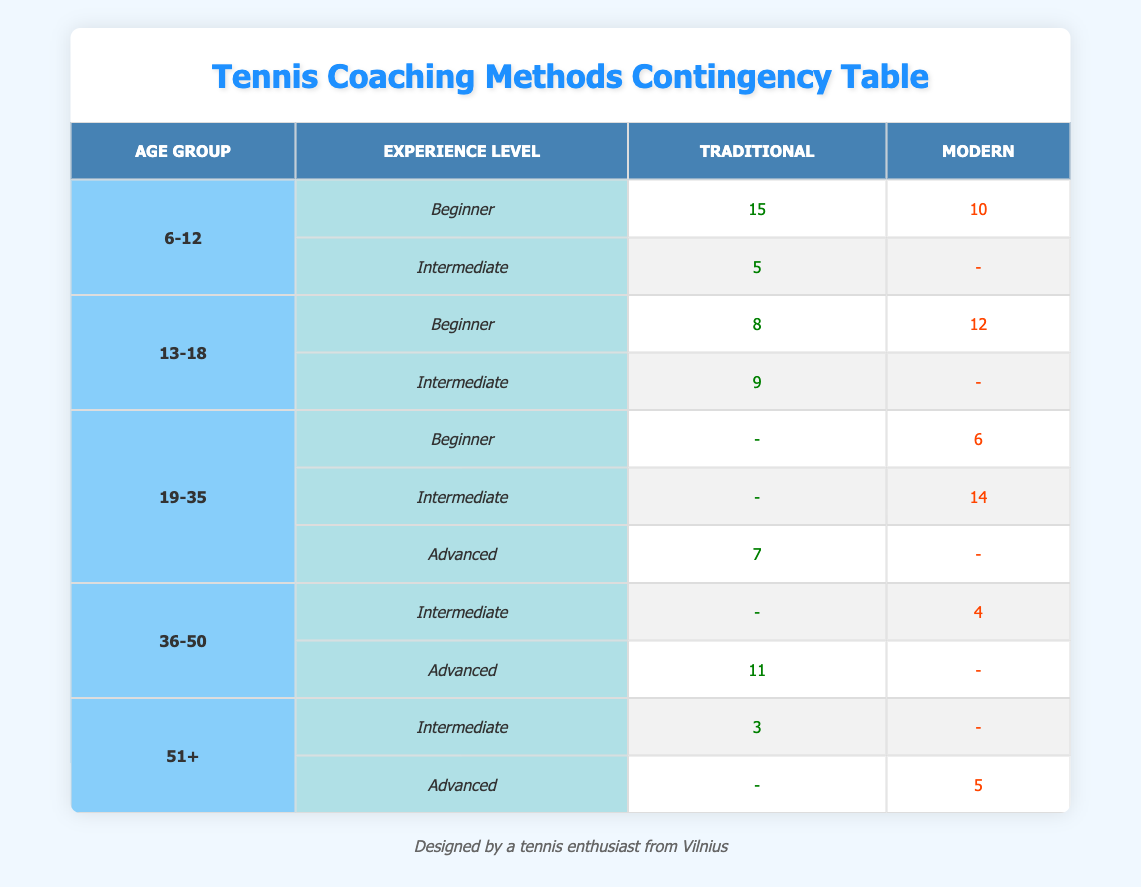What is the count of beginners in the age group 6-12 who prefer traditional coaching methods? In the table, under the age group 6-12 and experience level Beginner, the count for traditional coaching methods is 15.
Answer: 15 How many total responses are there for the age group 19-35? For the age group 19-35, the counts are: 6 (Beginner, Modern), 14 (Intermediate, Modern), and 7 (Advanced, Traditional). Summing these gives 6 + 14 + 7 = 27.
Answer: 27 Is there any age group that has no responses for the modern coaching method? Examining the table, the 6-12 and 36-50 age groups have counts for all experience levels with modern coaching methods, but the age group 51+ has no responses for Intermediate modern coaching. Therefore, the answer is yes.
Answer: Yes What is the total count of individuals in the age group 36-50 that prefer traditional coaching methods? For the age group 36-50, the counts for traditional coaching methods are: 11 (Advanced) and 0 (Intermediate). Adding these gives 11 + 0 = 11.
Answer: 11 Which coaching method is more preferred by beginners in the age group 13-18? Looking at the age group 13-18 for beginners, the count for traditional coaching methods is 8, while for modern methods it is 12. Since 12 is greater than 8, modern coaching methods are preferred.
Answer: Modern How many more individuals in the age group 51+ prefer advanced modern coaching methods compared to intermediate traditional methods? For the age group 51+, the count for advanced modern coaching methods is 5 and for intermediate traditional methods it is 3. Thus, there are 5 - 3 = 2 more individuals preferring advanced modern coaching methods.
Answer: 2 What is the age group with the highest count for traditional coaching methods, and what is that count? Assessing the counts for traditional coaching methods across all age groups: 15 (6-12, Beginner), 9 (13-18, Intermediate), 7 (19-35, Advanced), 11 (36-50, Advanced), and 3 (51+, Intermediate). The highest count is 15 in the age group 6-12.
Answer: 6-12, 15 Are there more beginners or advanced individuals preferring modern coaching methods across all age groups combined? Summing all counts for beginners in modern coaching methods yields 10 (6-12) + 12 (13-18) + 6 (19-35) = 28. For advanced modern, it is 5 (51+). Therefore, 28 > 5, indicating more beginners prefer modern coaching methods.
Answer: Beginners Which experience level has the highest count for traditional coaching methods in all age groups? By inspecting the counts for traditional methods: 15 (6-12, Beginner), 9 (13-18, Intermediate), 7 (19-35, Advanced), 11 (36-50, Advanced), and 3 (51+, Intermediate). The highest count is 15 for the Beginner level in the age group 6-12.
Answer: Beginner, 15 